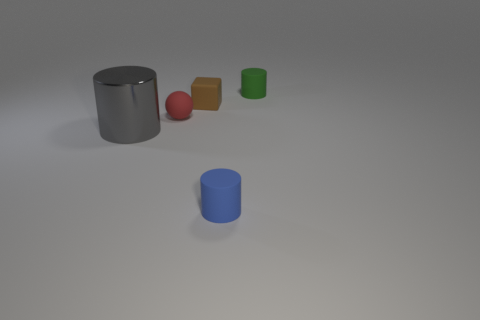Is there anything else that has the same material as the gray thing?
Your answer should be very brief. No. Does the large cylinder have the same color as the tiny rubber cube?
Offer a very short reply. No. The red rubber object is what size?
Provide a succinct answer. Small. There is a thing on the right side of the matte cylinder in front of the big gray cylinder; how many tiny rubber cylinders are in front of it?
Provide a succinct answer. 1. There is a small object that is to the right of the matte cylinder in front of the tiny red sphere; what is its shape?
Give a very brief answer. Cylinder. There is a gray thing that is the same shape as the tiny green thing; what size is it?
Your answer should be very brief. Large. Is there anything else that has the same size as the red object?
Your answer should be very brief. Yes. There is a small rubber cylinder that is behind the big gray shiny thing; what is its color?
Ensure brevity in your answer.  Green. The tiny cylinder that is left of the tiny rubber thing that is to the right of the tiny object in front of the big gray object is made of what material?
Your answer should be very brief. Rubber. There is a red thing on the left side of the small cylinder to the left of the green matte cylinder; what is its size?
Offer a very short reply. Small. 